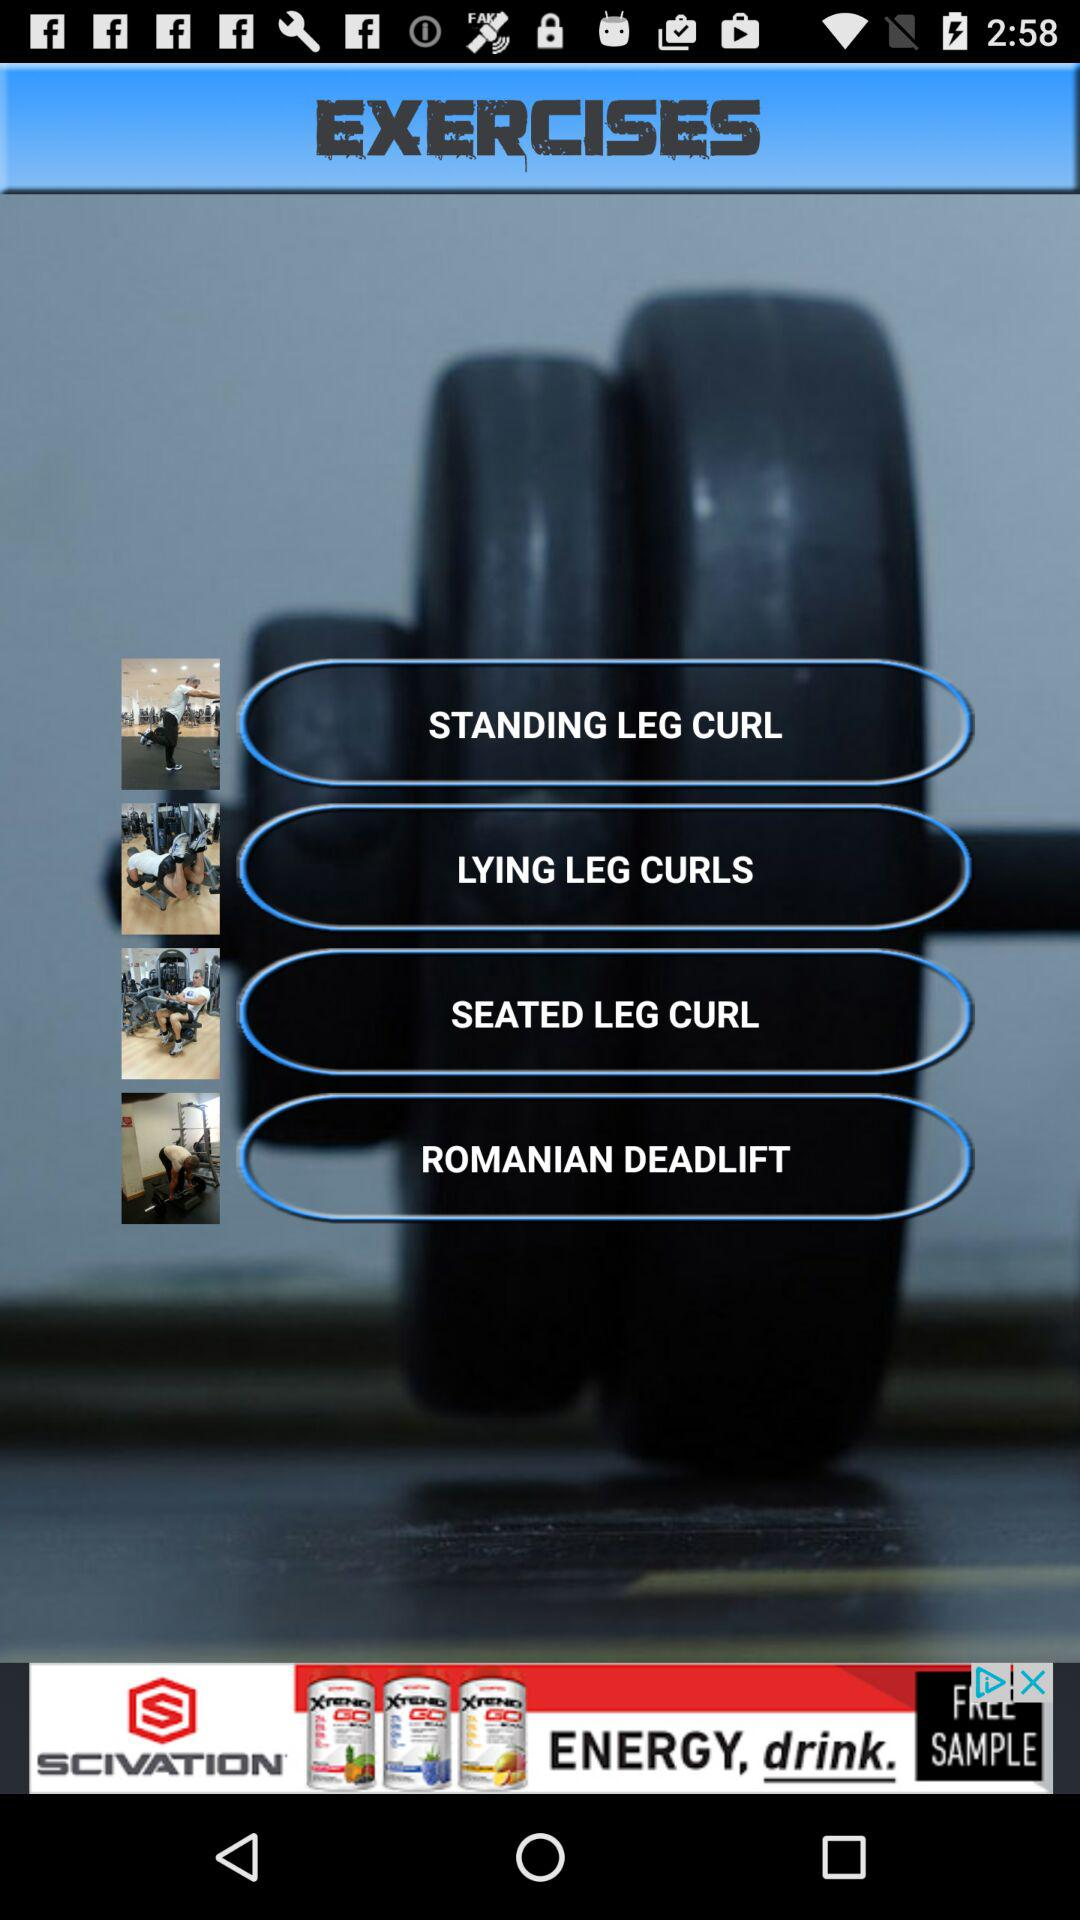What is the application name? The application name is "EXERCISES". 